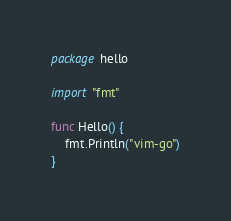<code> <loc_0><loc_0><loc_500><loc_500><_Go_>package hello

import "fmt"

func Hello() {
	fmt.Println("vim-go")
}
</code> 